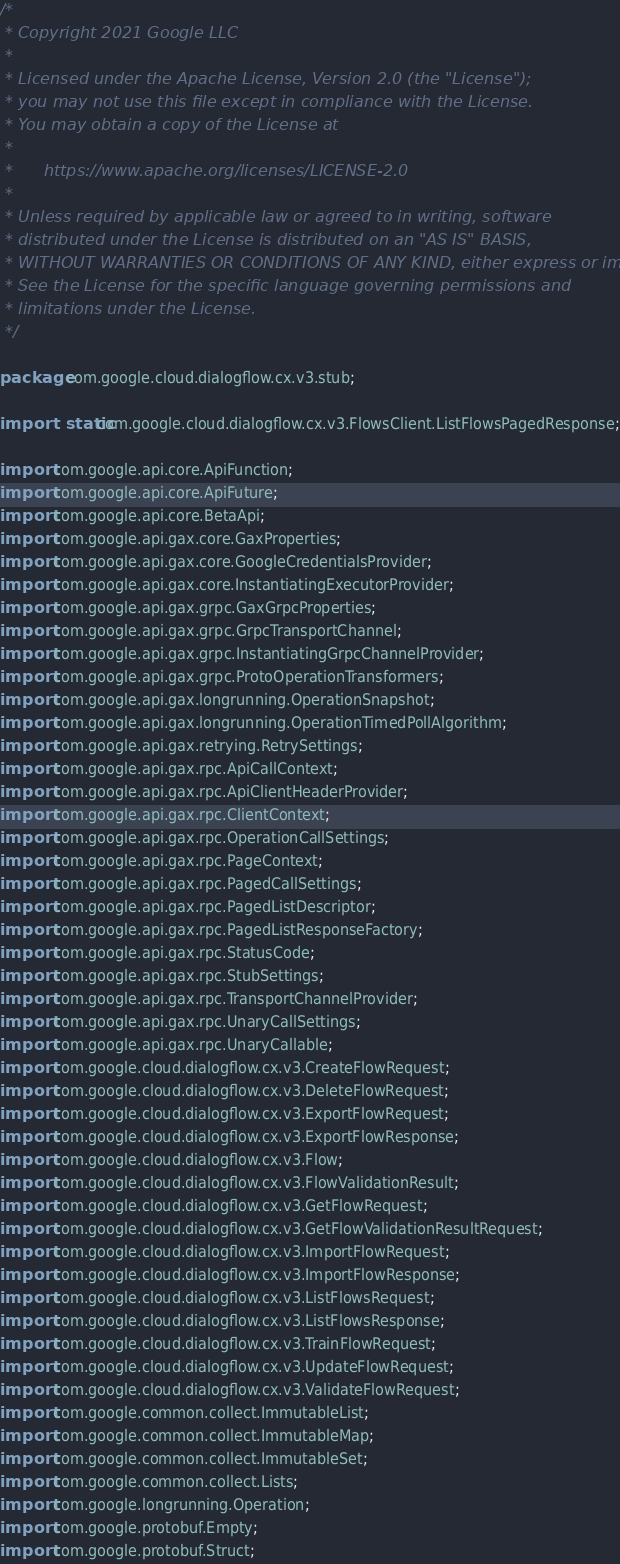Convert code to text. <code><loc_0><loc_0><loc_500><loc_500><_Java_>/*
 * Copyright 2021 Google LLC
 *
 * Licensed under the Apache License, Version 2.0 (the "License");
 * you may not use this file except in compliance with the License.
 * You may obtain a copy of the License at
 *
 *      https://www.apache.org/licenses/LICENSE-2.0
 *
 * Unless required by applicable law or agreed to in writing, software
 * distributed under the License is distributed on an "AS IS" BASIS,
 * WITHOUT WARRANTIES OR CONDITIONS OF ANY KIND, either express or implied.
 * See the License for the specific language governing permissions and
 * limitations under the License.
 */

package com.google.cloud.dialogflow.cx.v3.stub;

import static com.google.cloud.dialogflow.cx.v3.FlowsClient.ListFlowsPagedResponse;

import com.google.api.core.ApiFunction;
import com.google.api.core.ApiFuture;
import com.google.api.core.BetaApi;
import com.google.api.gax.core.GaxProperties;
import com.google.api.gax.core.GoogleCredentialsProvider;
import com.google.api.gax.core.InstantiatingExecutorProvider;
import com.google.api.gax.grpc.GaxGrpcProperties;
import com.google.api.gax.grpc.GrpcTransportChannel;
import com.google.api.gax.grpc.InstantiatingGrpcChannelProvider;
import com.google.api.gax.grpc.ProtoOperationTransformers;
import com.google.api.gax.longrunning.OperationSnapshot;
import com.google.api.gax.longrunning.OperationTimedPollAlgorithm;
import com.google.api.gax.retrying.RetrySettings;
import com.google.api.gax.rpc.ApiCallContext;
import com.google.api.gax.rpc.ApiClientHeaderProvider;
import com.google.api.gax.rpc.ClientContext;
import com.google.api.gax.rpc.OperationCallSettings;
import com.google.api.gax.rpc.PageContext;
import com.google.api.gax.rpc.PagedCallSettings;
import com.google.api.gax.rpc.PagedListDescriptor;
import com.google.api.gax.rpc.PagedListResponseFactory;
import com.google.api.gax.rpc.StatusCode;
import com.google.api.gax.rpc.StubSettings;
import com.google.api.gax.rpc.TransportChannelProvider;
import com.google.api.gax.rpc.UnaryCallSettings;
import com.google.api.gax.rpc.UnaryCallable;
import com.google.cloud.dialogflow.cx.v3.CreateFlowRequest;
import com.google.cloud.dialogflow.cx.v3.DeleteFlowRequest;
import com.google.cloud.dialogflow.cx.v3.ExportFlowRequest;
import com.google.cloud.dialogflow.cx.v3.ExportFlowResponse;
import com.google.cloud.dialogflow.cx.v3.Flow;
import com.google.cloud.dialogflow.cx.v3.FlowValidationResult;
import com.google.cloud.dialogflow.cx.v3.GetFlowRequest;
import com.google.cloud.dialogflow.cx.v3.GetFlowValidationResultRequest;
import com.google.cloud.dialogflow.cx.v3.ImportFlowRequest;
import com.google.cloud.dialogflow.cx.v3.ImportFlowResponse;
import com.google.cloud.dialogflow.cx.v3.ListFlowsRequest;
import com.google.cloud.dialogflow.cx.v3.ListFlowsResponse;
import com.google.cloud.dialogflow.cx.v3.TrainFlowRequest;
import com.google.cloud.dialogflow.cx.v3.UpdateFlowRequest;
import com.google.cloud.dialogflow.cx.v3.ValidateFlowRequest;
import com.google.common.collect.ImmutableList;
import com.google.common.collect.ImmutableMap;
import com.google.common.collect.ImmutableSet;
import com.google.common.collect.Lists;
import com.google.longrunning.Operation;
import com.google.protobuf.Empty;
import com.google.protobuf.Struct;</code> 